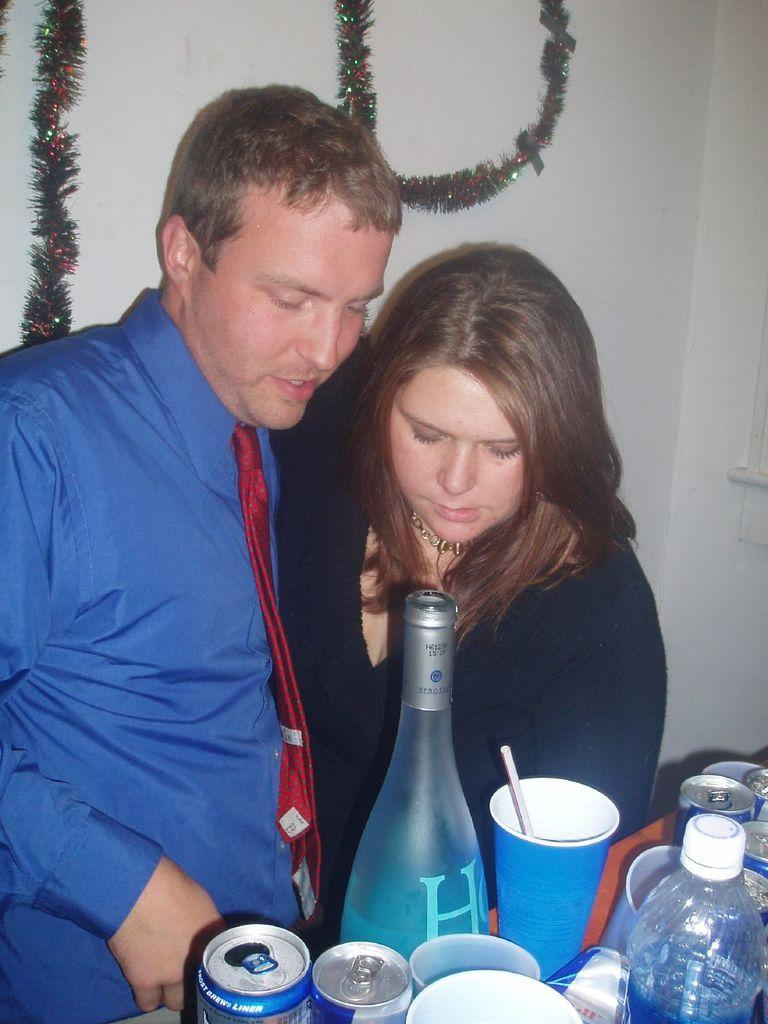How many people are in the image? There are two people in the image. What are the people doing in the image? The people are standing. What is in front of the people? There is a table in front of the people. What beverages are on the table? There is a wine bottle and coke cans on the table. What type of game is being played on the table in the image? There is no game present on the table in the image. Is there an oven visible in the image? There is no oven visible in the image. 